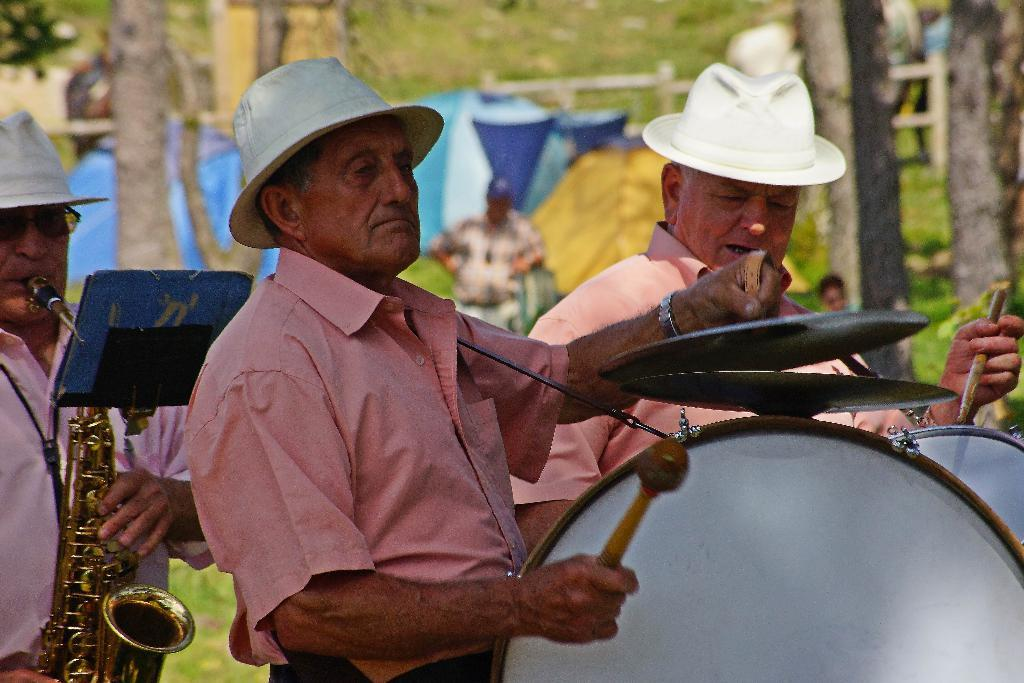How many men are in the image? There are three men in the image. What are the men doing in the image? One of the men is playing drums, and another is playing a saxophone. Can you describe the background of the image? There are tents, grass, a fence, and trees in the background. Are there any other people visible in the image? Yes, there is at least one other person standing in the background. What is the name of the wound on the saxophone player's hand? There is no wound visible on the saxophone player's hand in the image. 